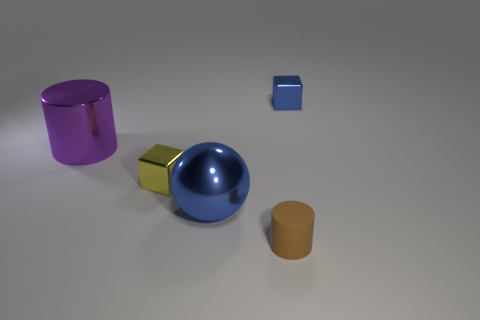Add 3 blue cubes. How many objects exist? 8 Subtract all spheres. How many objects are left? 4 Subtract 0 cyan cubes. How many objects are left? 5 Subtract all large gray cylinders. Subtract all purple metallic things. How many objects are left? 4 Add 5 yellow blocks. How many yellow blocks are left? 6 Add 2 small yellow shiny things. How many small yellow shiny things exist? 3 